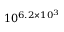<formula> <loc_0><loc_0><loc_500><loc_500>1 0 ^ { \, 6 . 2 \times 1 0 ^ { 3 } }</formula> 